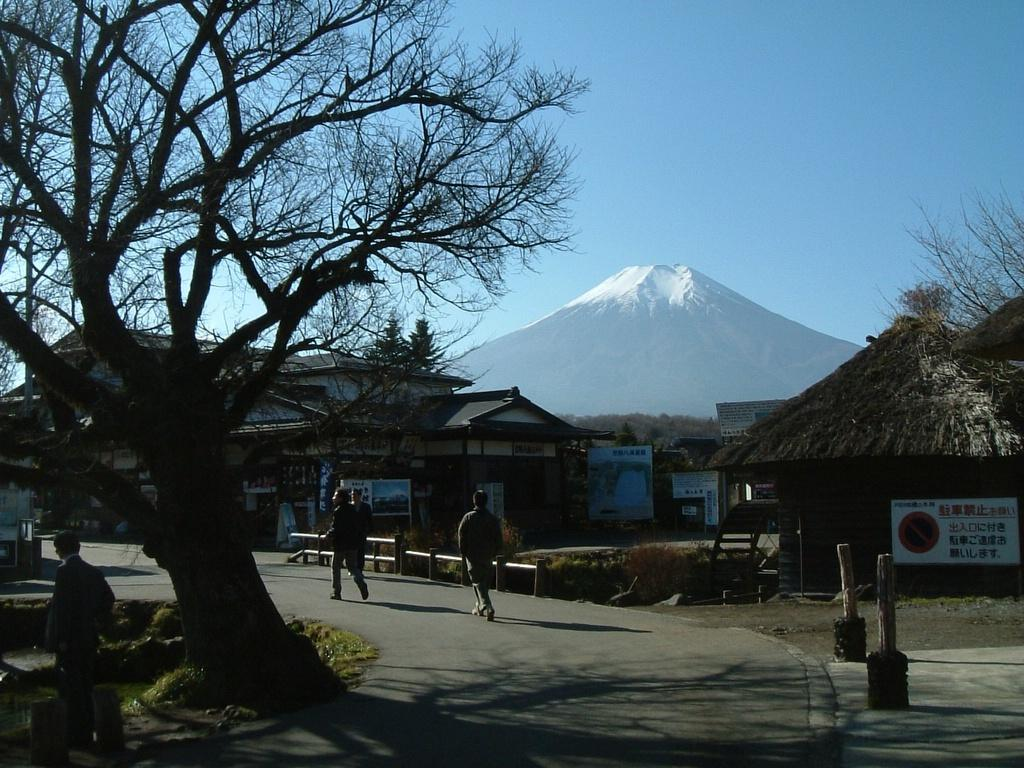What type of vegetation can be seen in the image? There are trees in the image. What are the people in the image doing? Some people are walking on a road. What can be seen in the background of the image? There are hoardings, houses, and a hill visible in the background of the image. What type of flame can be seen coming from the houses in the image? There is no flame present in the image; the houses are not on fire. What type of insurance policy are the people discussing while walking on the road? There is no indication in the image that the people are discussing insurance or any other topic. 